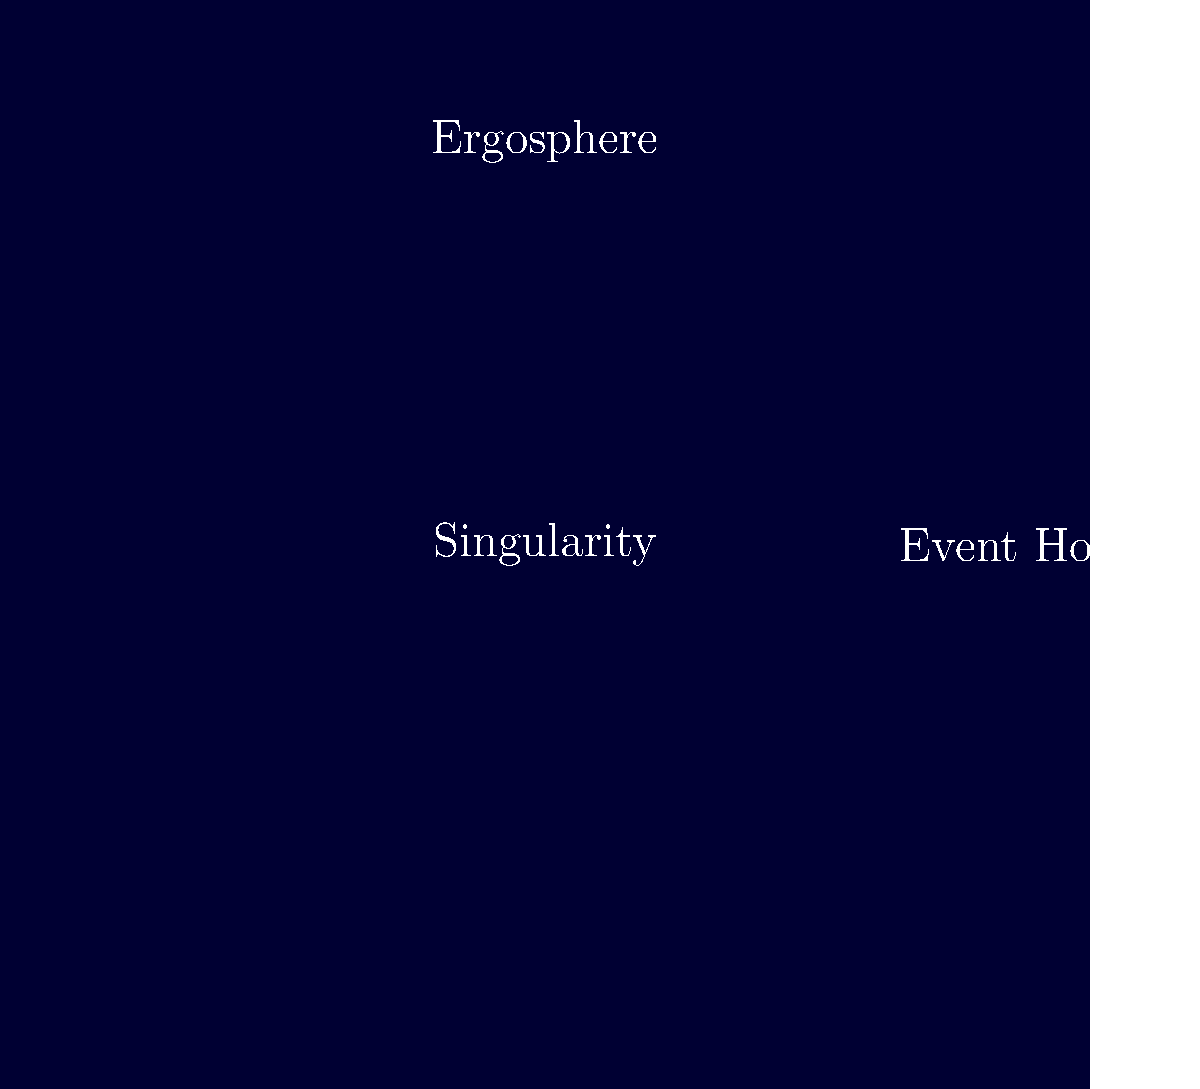In the cross-sectional diagram of a rotating black hole, what is the region between the event horizon and the outer dashed line called, and what unique property does it exhibit that could potentially be exploited for energy extraction? To answer this question, let's break down the structure of a rotating black hole:

1. The central point represents the singularity, where the mass is concentrated.

2. The solid white circle represents the event horizon, the boundary beyond which nothing can escape the black hole's gravitational pull.

3. The dashed white line represents the outer boundary of a region called the ergosphere.

4. The region between the event horizon and the ergosphere is what we're focusing on.

This region is called the ergosphere. It has a unique property:

5. In the ergosphere, spacetime is dragged along with the rotation of the black hole. This effect is called frame-dragging.

6. Due to frame-dragging, objects in the ergosphere are forced to rotate in the same direction as the black hole.

7. Importantly, while light and matter cannot escape from within the event horizon, they can escape from the ergosphere.

8. This unique property allows for the theoretical possibility of energy extraction from a rotating black hole through a process called the Penrose process.

9. In the Penrose process, an object entering the ergosphere could be split in two. One part falls into the black hole, while the other escapes with more energy than the original object had when entering the ergosphere.

This potential for energy extraction makes the ergosphere a region of particular interest in black hole physics and theoretical astrophysics.
Answer: The ergosphere; it exhibits frame-dragging and allows potential energy extraction via the Penrose process. 